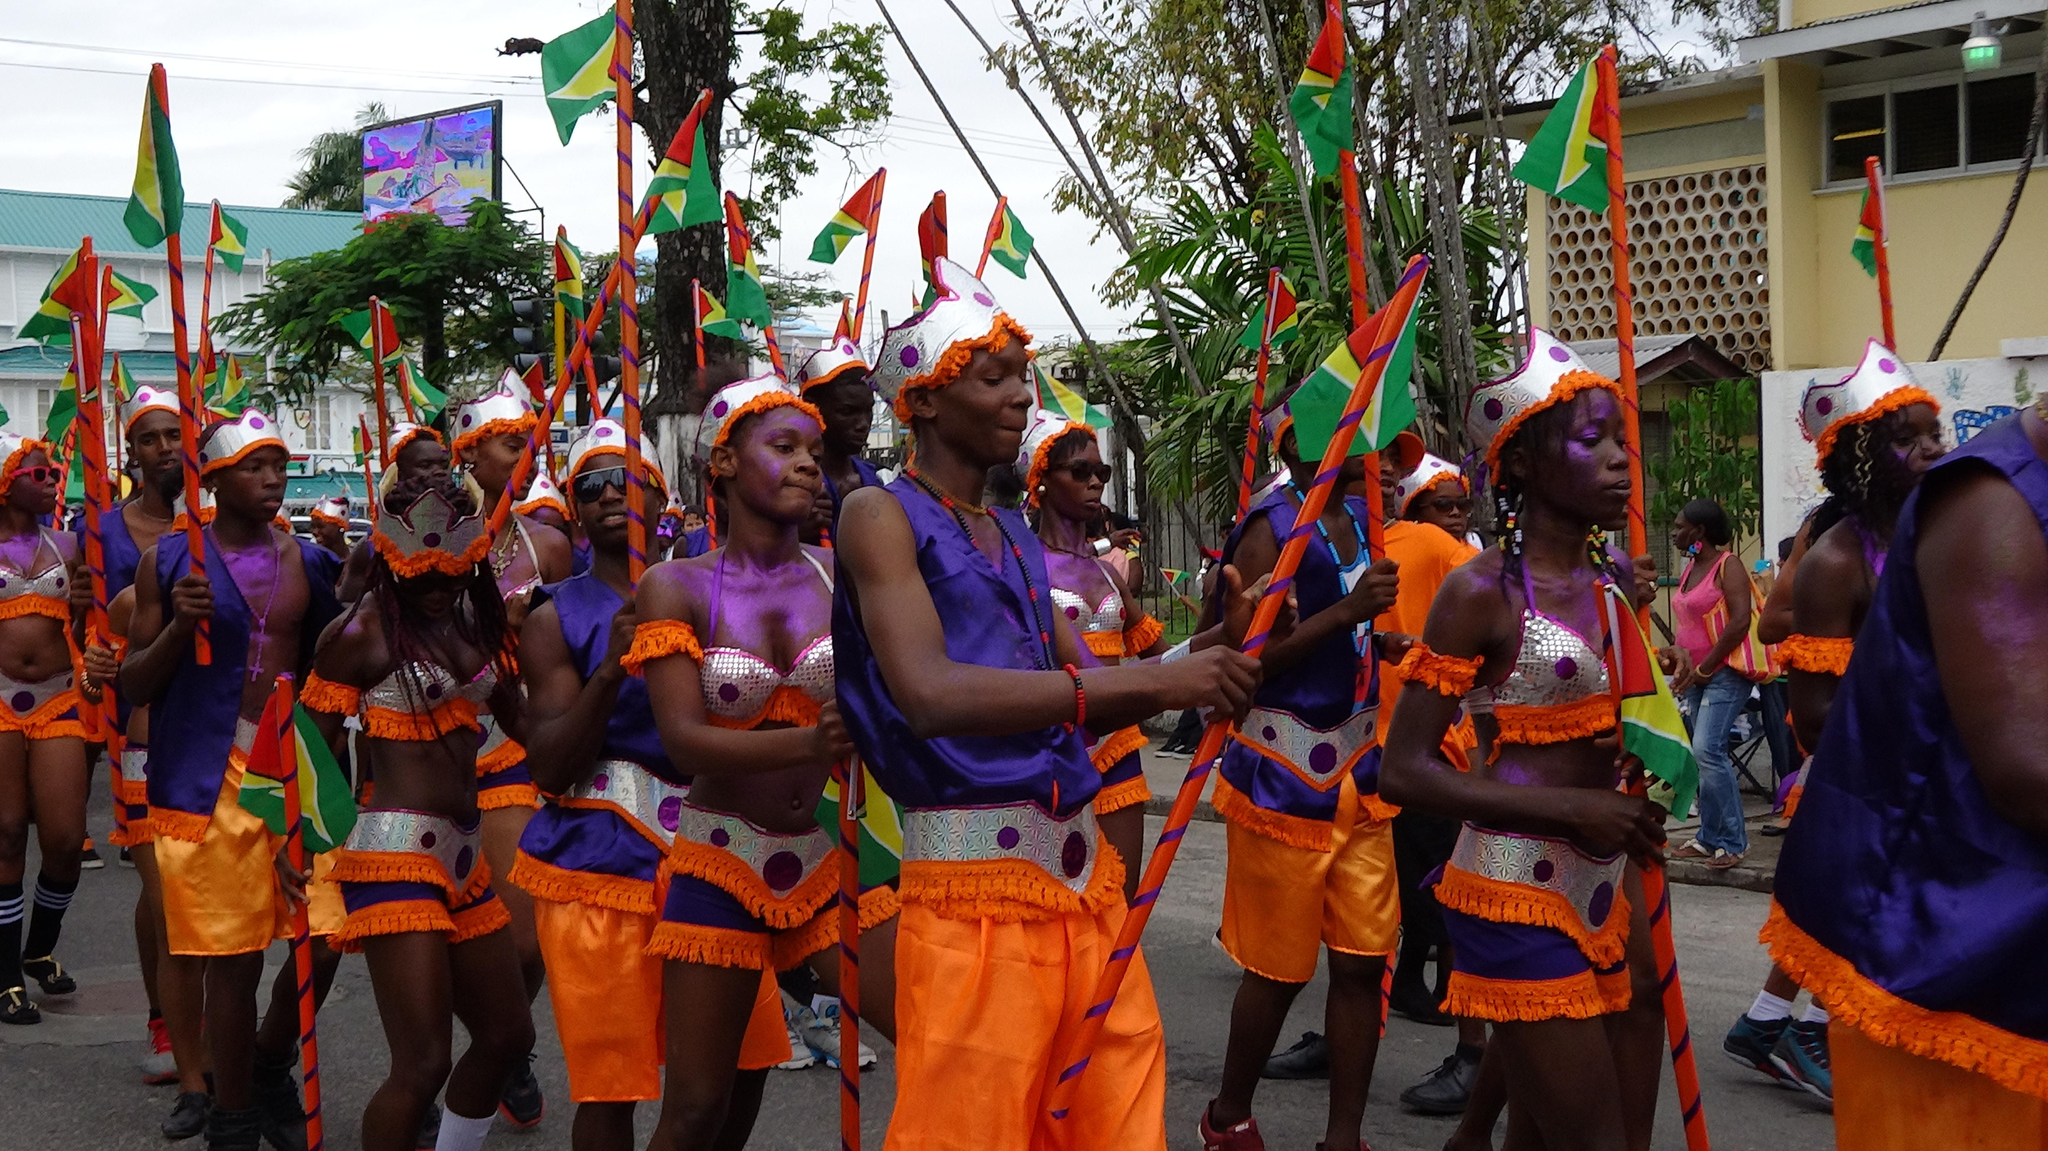How many people are in the image? There is a group of people in the image, but the exact number is not specified. What are the people wearing in the image? The people are wearing fancy dresses in the image. What are the people holding in the image? The people are holding objects in the image. What can be seen in the background of the image? There are trees, buildings, a board, and the sky visible in the background of the image. Can you see any fangs on the people in the image? There are no fangs visible on the people in the image. Is there a bridge in the background of the image? There is no mention of a bridge in the provided facts, so it cannot be confirmed from the image. 